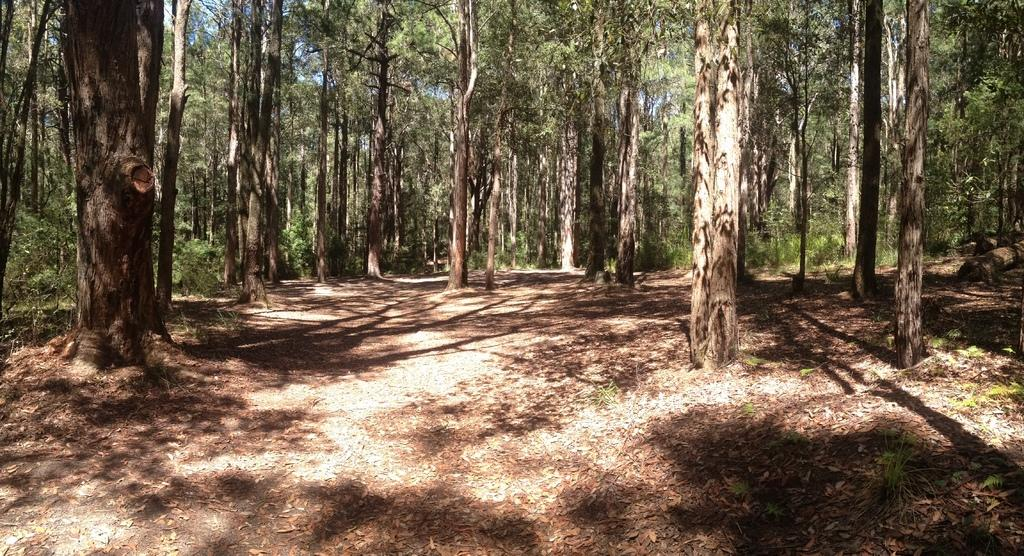What type of location is depicted in the image? The image shows an open area. What natural elements can be seen in the image? There are multiple trees in the image. What can be observed on the ground in the image? Shadows are visible on the ground in the image. What type of rose is growing near the trees in the image? There is no rose present in the image; it only shows trees and an open area. 